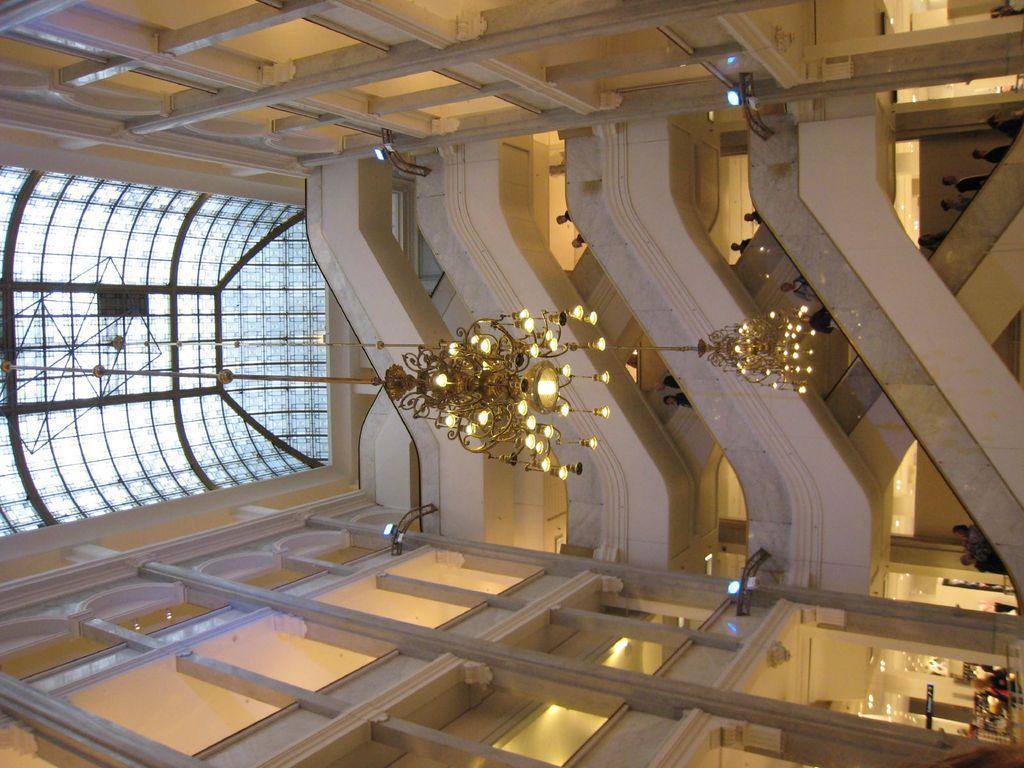Could you give a brief overview of what you see in this image? In this picture we can see inside view of the building. In the front we can some steps and hanging chandeliers. On the top there is a glass roof. 